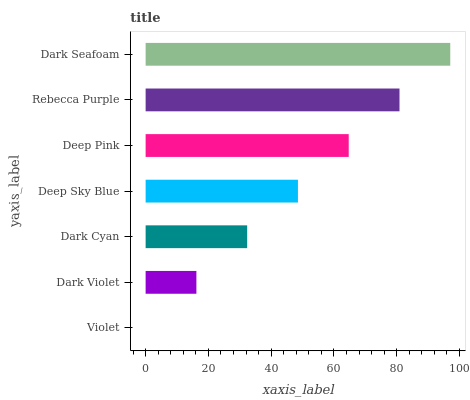Is Violet the minimum?
Answer yes or no. Yes. Is Dark Seafoam the maximum?
Answer yes or no. Yes. Is Dark Violet the minimum?
Answer yes or no. No. Is Dark Violet the maximum?
Answer yes or no. No. Is Dark Violet greater than Violet?
Answer yes or no. Yes. Is Violet less than Dark Violet?
Answer yes or no. Yes. Is Violet greater than Dark Violet?
Answer yes or no. No. Is Dark Violet less than Violet?
Answer yes or no. No. Is Deep Sky Blue the high median?
Answer yes or no. Yes. Is Deep Sky Blue the low median?
Answer yes or no. Yes. Is Dark Seafoam the high median?
Answer yes or no. No. Is Deep Pink the low median?
Answer yes or no. No. 